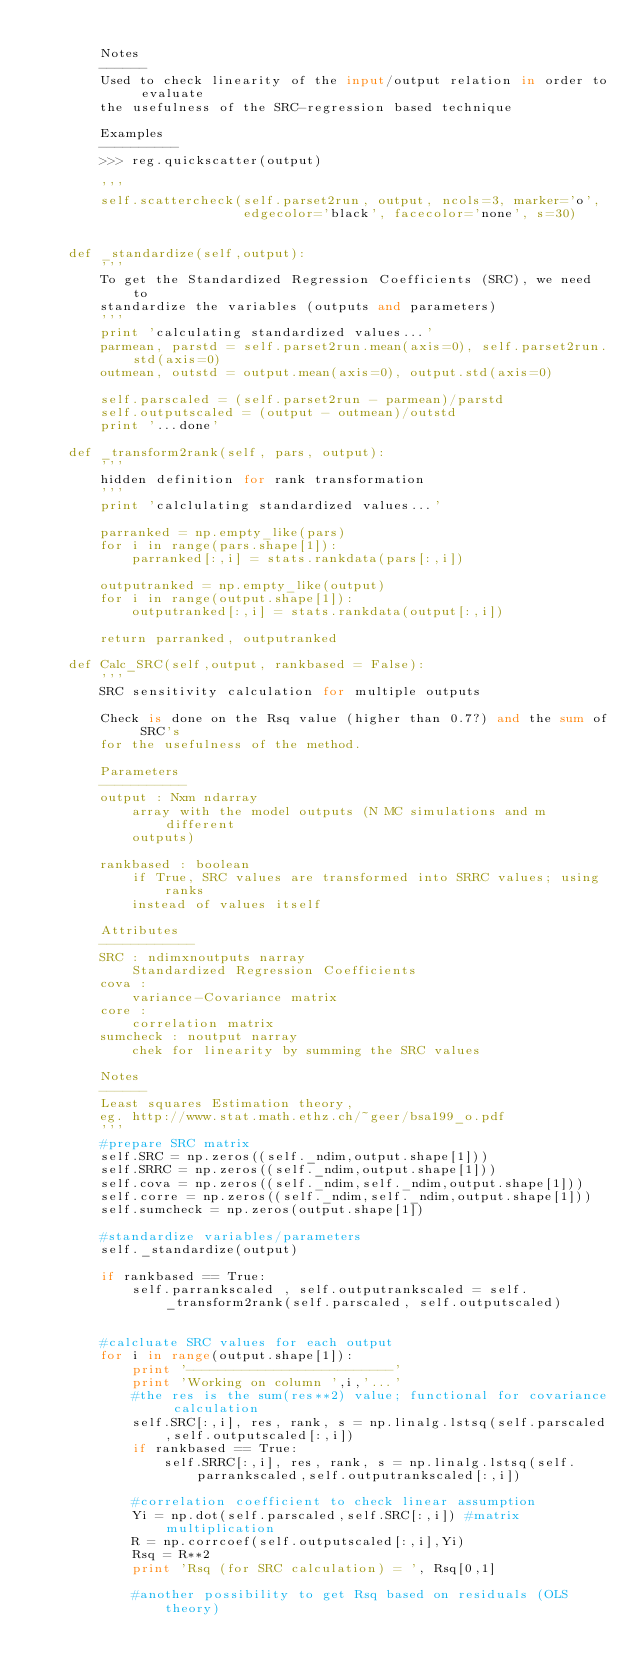<code> <loc_0><loc_0><loc_500><loc_500><_Python_>            
        Notes
        ------
        Used to check linearity of the input/output relation in order to evaluate
        the usefulness of the SRC-regression based technique
        
        Examples
        ----------
        >>> reg.quickscatter(output)
        
        '''
        self.scattercheck(self.parset2run, output, ncols=3, marker='o', 
                          edgecolor='black', facecolor='none', s=30)
    

    def _standardize(self,output):
        '''
        To get the Standardized Regression Coefficients (SRC), we need to 
        standardize the variables (outputs and parameters)        
        '''
        print 'calculating standardized values...'
        parmean, parstd = self.parset2run.mean(axis=0), self.parset2run.std(axis=0)
        outmean, outstd = output.mean(axis=0), output.std(axis=0)
        
        self.parscaled = (self.parset2run - parmean)/parstd
        self.outputscaled = (output - outmean)/outstd        
        print '...done'

    def _transform2rank(self, pars, output):
        '''
        hidden definition for rank transformation
        '''        
        print 'calclulating standardized values...'
        
        parranked = np.empty_like(pars)
        for i in range(pars.shape[1]):
            parranked[:,i] = stats.rankdata(pars[:,i])
        
        outputranked = np.empty_like(output)            
        for i in range(output.shape[1]):
            outputranked[:,i] = stats.rankdata(output[:,i])
        
        return parranked, outputranked

    def Calc_SRC(self,output, rankbased = False):
        '''
        SRC sensitivity calculation for multiple outputs
        
        Check is done on the Rsq value (higher than 0.7?) and the sum of SRC's
        for the usefulness of the method.
        
        Parameters
        -----------
        output : Nxm ndarray
            array with the model outputs (N MC simulations and m different 
            outputs)
        
        rankbased : boolean
            if True, SRC values are transformed into SRRC values; using ranks 
            instead of values itself
        
        Attributes
        ------------
        SRC : ndimxnoutputs narray
            Standardized Regression Coefficients
        cova : 
            variance-Covariance matrix
        core : 
            correlation matrix
        sumcheck : noutput narray
            chek for linearity by summing the SRC values
                        
        Notes
        ------
        Least squares Estimation theory, 
        eg. http://www.stat.math.ethz.ch/~geer/bsa199_o.pdf
        '''
        #prepare SRC matrix
        self.SRC = np.zeros((self._ndim,output.shape[1]))
        self.SRRC = np.zeros((self._ndim,output.shape[1]))
        self.cova = np.zeros((self._ndim,self._ndim,output.shape[1]))
        self.corre = np.zeros((self._ndim,self._ndim,output.shape[1]))
        self.sumcheck = np.zeros(output.shape[1])
     
        #standardize variables/parameters
        self._standardize(output)
        
        if rankbased == True:
            self.parrankscaled , self.outputrankscaled = self._transform2rank(self.parscaled, self.outputscaled)
            
        
        #calcluate SRC values for each output
        for i in range(output.shape[1]):
            print '--------------------------'
            print 'Working on column ',i,'...'
            #the res is the sum(res**2) value; functional for covariance calculation
            self.SRC[:,i], res, rank, s = np.linalg.lstsq(self.parscaled,self.outputscaled[:,i])
            if rankbased == True:
                self.SRRC[:,i], res, rank, s = np.linalg.lstsq(self.parrankscaled,self.outputrankscaled[:,i])
            
            #correlation coefficient to check linear assumption
            Yi = np.dot(self.parscaled,self.SRC[:,i]) #matrix multiplication
            R = np.corrcoef(self.outputscaled[:,i],Yi)
            Rsq = R**2
            print 'Rsq (for SRC calculation) = ', Rsq[0,1]
                                           
            #another possibility to get Rsq based on residuals (OLS theory)</code> 